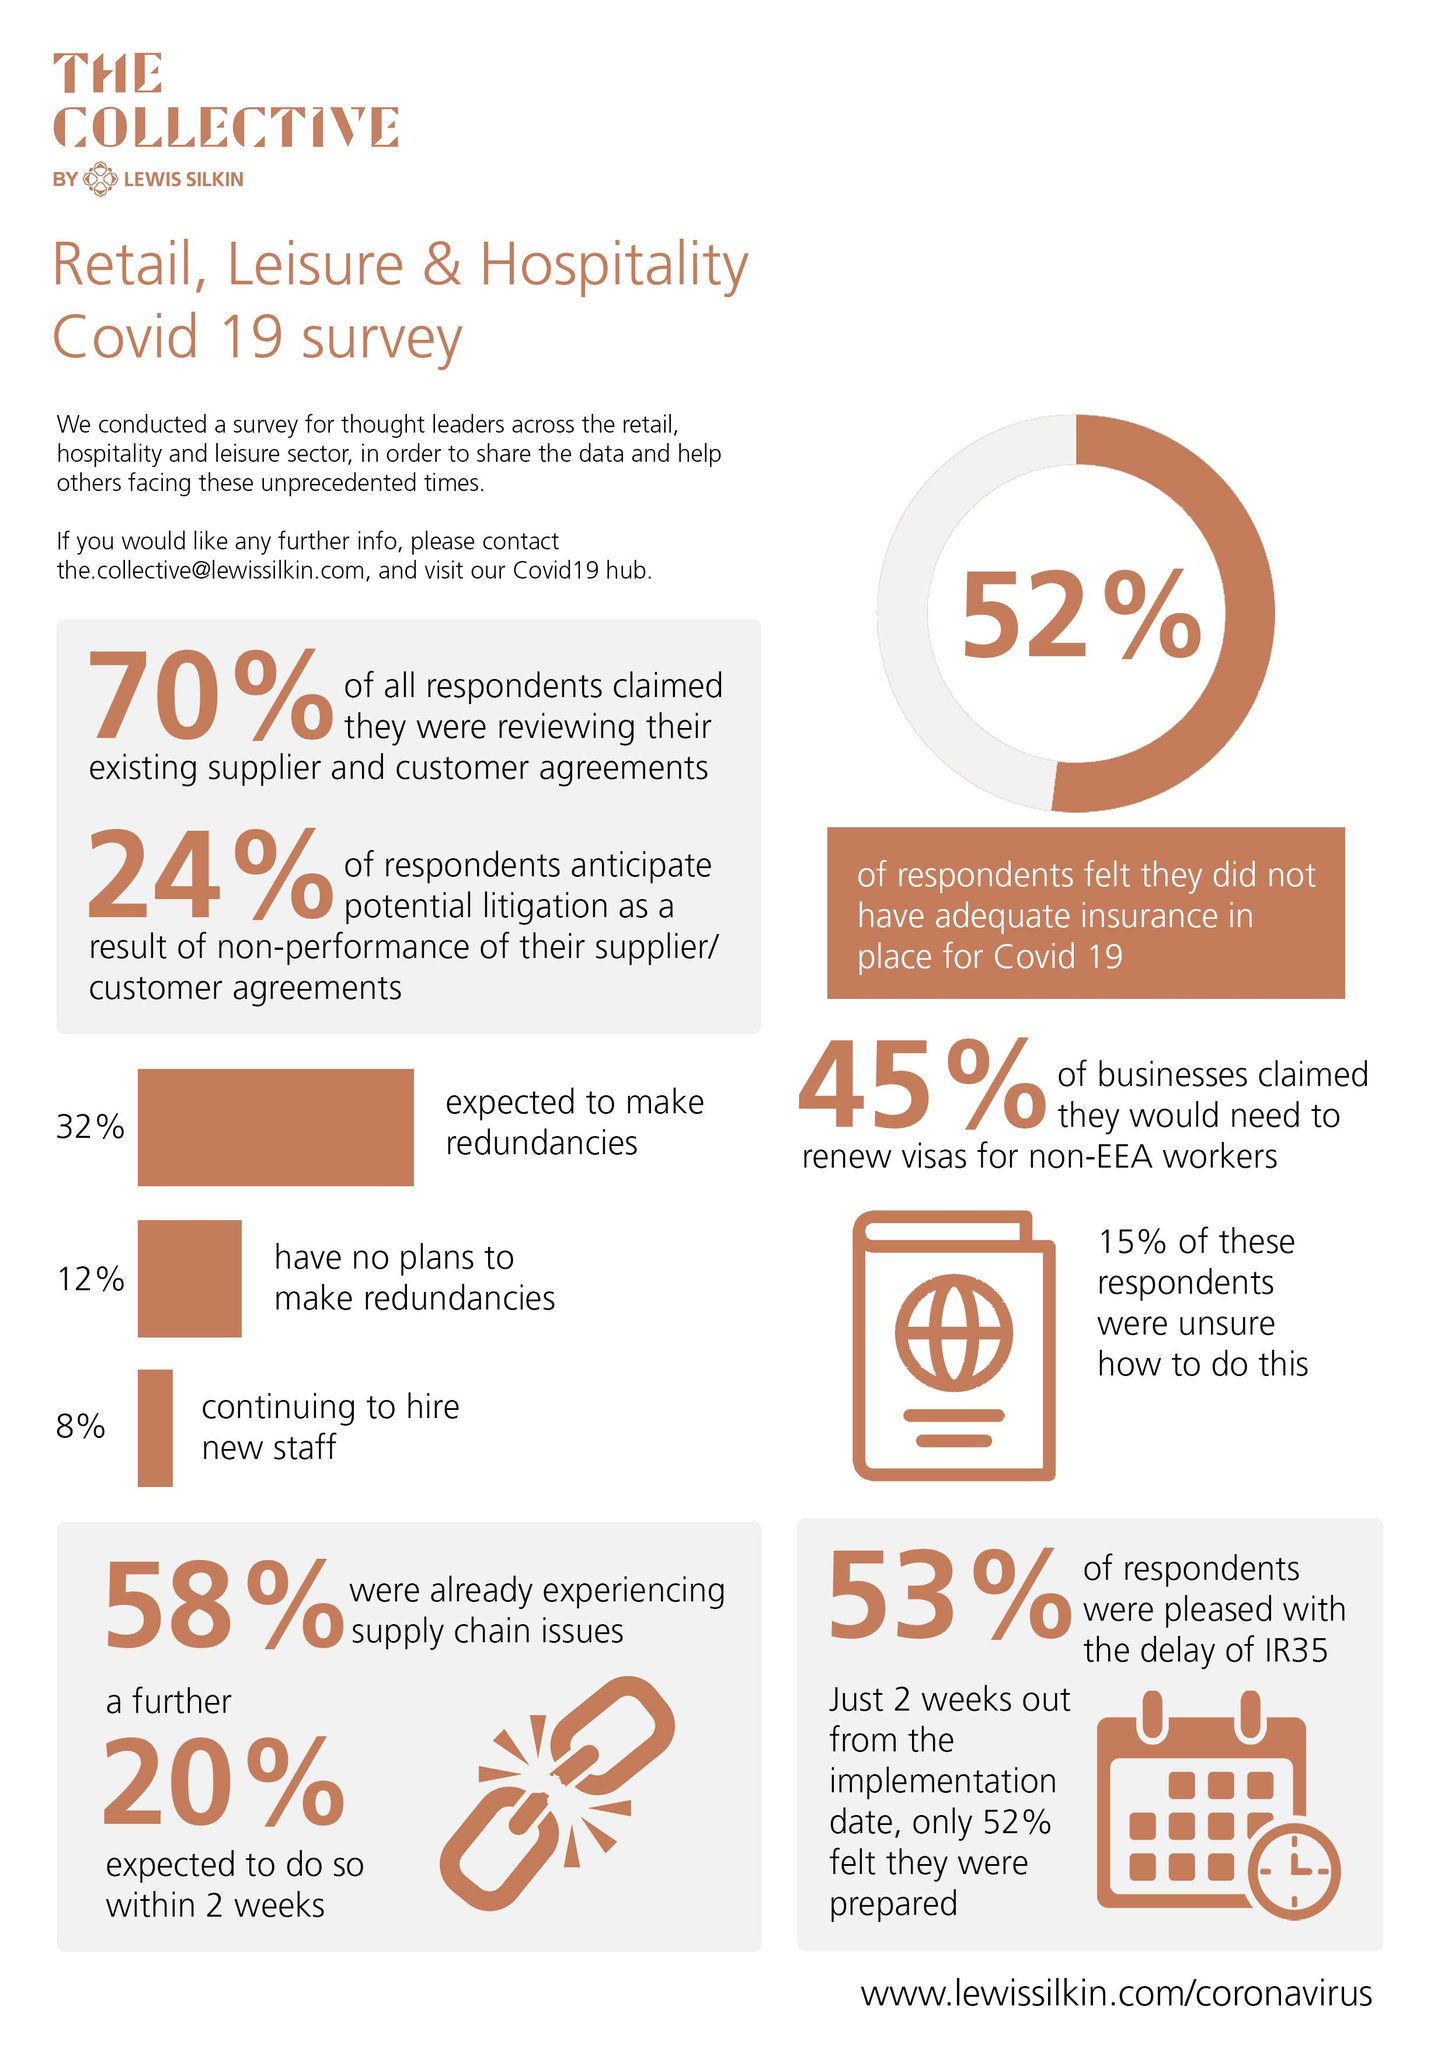List a handful of essential elements in this visual. In the survey, 92% of respondents reported that they had stopped hiring new staff. 